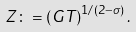<formula> <loc_0><loc_0><loc_500><loc_500>Z \colon = \left ( G T \right ) ^ { 1 / ( 2 - \sigma ) } .</formula> 